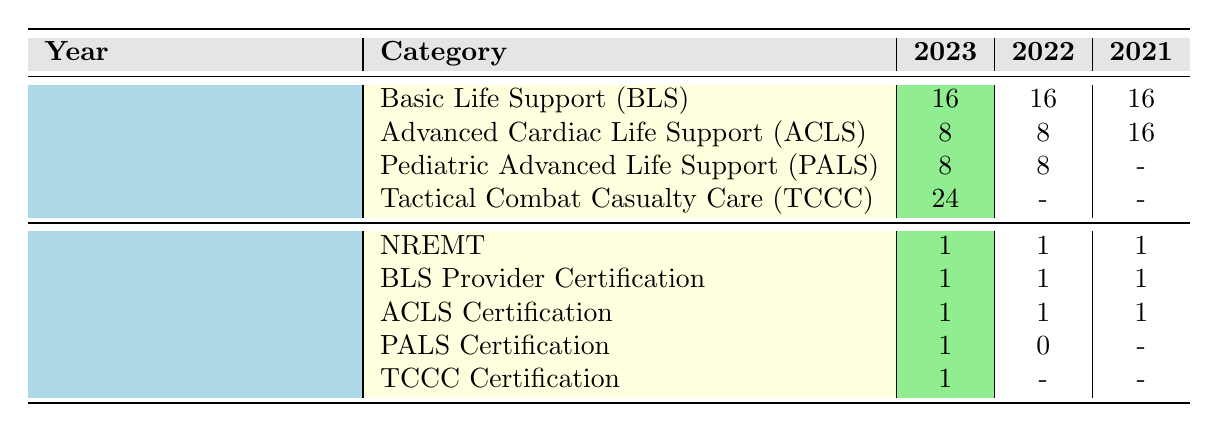What is the total number of training hours for Basic Life Support (BLS) in 2023? The table shows that the training hours for Basic Life Support (BLS) in 2023 are 16 hours.
Answer: 16 How many certifications were completed in 2022? In 2022, the table lists the certifications as follows: NREMT (1), BLS Provider Certification (1), ACLS Certification (1), and PALS Certification (0), totaling 3 certifications completed.
Answer: 3 Was Tactical Combat Casualty Care (TCCC) training completed in 2022? The table indicates that TCCC training hours are not listed for 2022, implying it was not completed that year.
Answer: No What is the average number of training hours for Advanced Cardiac Life Support (ACLS) over the three years? The table lists ACLS training hours as 8 (2023), 8 (2022), and 16 (2021). The total hours are 8 + 8 + 16 = 32 and dividing by 3 gives an average of 32/3, which is approximately 10.67 hours.
Answer: Approximately 10.67 How many certifications were completed for Pediatric Advanced Life Support (PALS) in 2021? The table indicates that there are no PALS certifications completed in 2021, as it shows a dash (-) under that category for the year.
Answer: 0 Did the number of certifications completed for Pediatric Advanced Life Support (PALS) increase from 2021 to 2022? In 2021, 0 certifications were completed for PALS, and in 2022, it increased to 1. Therefore, there is an increase from 0 to 1.
Answer: Yes What is the total number of certifications completed across all years? The number of certifications for each year is 4 (2023), 3 (2022), and 3 (2021). Summing these gives 4 + 3 + 3 = 10 certifications completed across all years.
Answer: 10 Which year had the highest number of training hours for Tactical Combat Casualty Care (TCCC)? The table shows that TCCC training is only listed for 2023 with 24 hours. There are no hours listed for other years, making 2023 the year with the highest hours for TCCC.
Answer: 2023 How many total certifications were completed in 2023? In 2023, the certifications completed are as follows: NREMT (1), BLS Provider Certification (1), ACLS Certification (1), PALS Certification (1), and TCCC Certification (1), making a total of 5 certifications completed in that year.
Answer: 5 